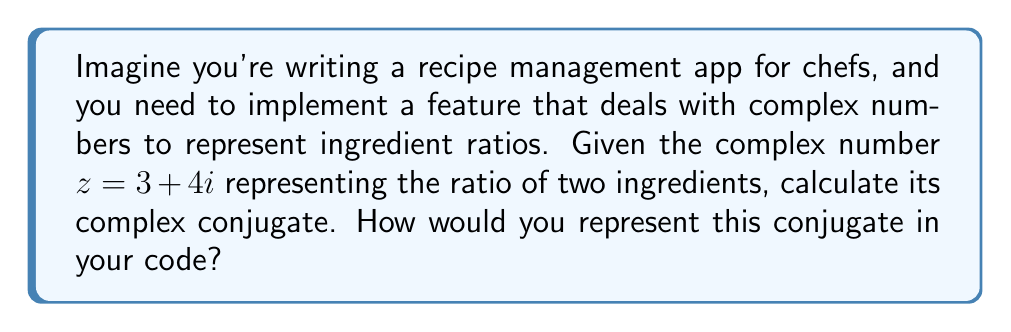Help me with this question. Let's approach this step-by-step:

1) The complex conjugate of a complex number $z = a + bi$ is defined as $\bar{z} = a - bi$.

2) In our case, we have $z = 3 + 4i$.

3) To find the conjugate, we keep the real part the same and change the sign of the imaginary part:

   $\bar{z} = 3 - 4i$

4) In code, you might represent this as two separate variables or as a tuple/array:
   - Real part: 3
   - Imaginary part: -4

5) If you're using a programming language with built-in complex number support, you might have a function like `conj(z)` or `z.conjugate()` to do this automatically.

Remember, the complex conjugate is useful in many calculations involving complex numbers, which could be relevant when dealing with more advanced recipe scaling or ingredient interaction modeling in your app.
Answer: $3 - 4i$ 